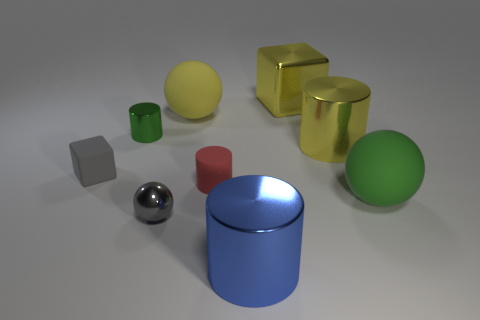Do the small rubber block and the metal sphere have the same color?
Ensure brevity in your answer.  Yes. What size is the object that is both behind the small green object and left of the tiny red cylinder?
Give a very brief answer. Large. The object that is the same color as the small metal ball is what shape?
Give a very brief answer. Cube. Are there any matte cubes of the same size as the gray metallic object?
Give a very brief answer. Yes. What is the color of the large cylinder behind the matte thing that is on the left side of the sphere that is behind the green shiny cylinder?
Your answer should be very brief. Yellow. Is the large blue object made of the same material as the large ball that is to the right of the big yellow cube?
Offer a very short reply. No. There is a yellow shiny object that is the same shape as the small gray rubber object; what size is it?
Provide a short and direct response. Large. Is the number of small shiny objects that are in front of the large green object the same as the number of red rubber objects to the right of the blue thing?
Make the answer very short. No. What number of other objects are there of the same material as the small red cylinder?
Give a very brief answer. 3. Is the number of green spheres left of the yellow sphere the same as the number of big yellow balls?
Give a very brief answer. No. 